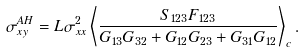Convert formula to latex. <formula><loc_0><loc_0><loc_500><loc_500>\sigma _ { x y } ^ { A H } = L \sigma _ { x x } ^ { 2 } \left \langle \frac { S _ { 1 2 3 } F _ { 1 2 3 } } { G _ { 1 3 } G _ { 3 2 } + G _ { 1 2 } G _ { 2 3 } + G _ { 3 1 } G _ { 1 2 } } \right \rangle _ { c } .</formula> 